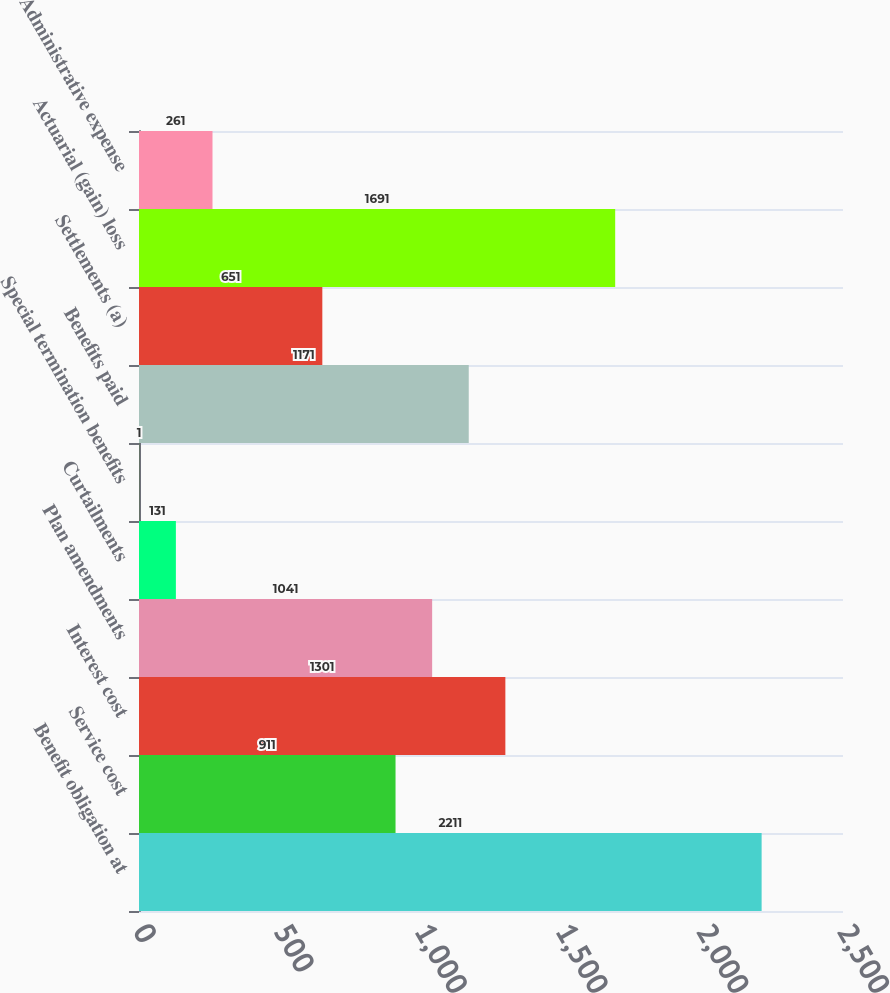Convert chart to OTSL. <chart><loc_0><loc_0><loc_500><loc_500><bar_chart><fcel>Benefit obligation at<fcel>Service cost<fcel>Interest cost<fcel>Plan amendments<fcel>Curtailments<fcel>Special termination benefits<fcel>Benefits paid<fcel>Settlements (a)<fcel>Actuarial (gain) loss<fcel>Administrative expense<nl><fcel>2211<fcel>911<fcel>1301<fcel>1041<fcel>131<fcel>1<fcel>1171<fcel>651<fcel>1691<fcel>261<nl></chart> 